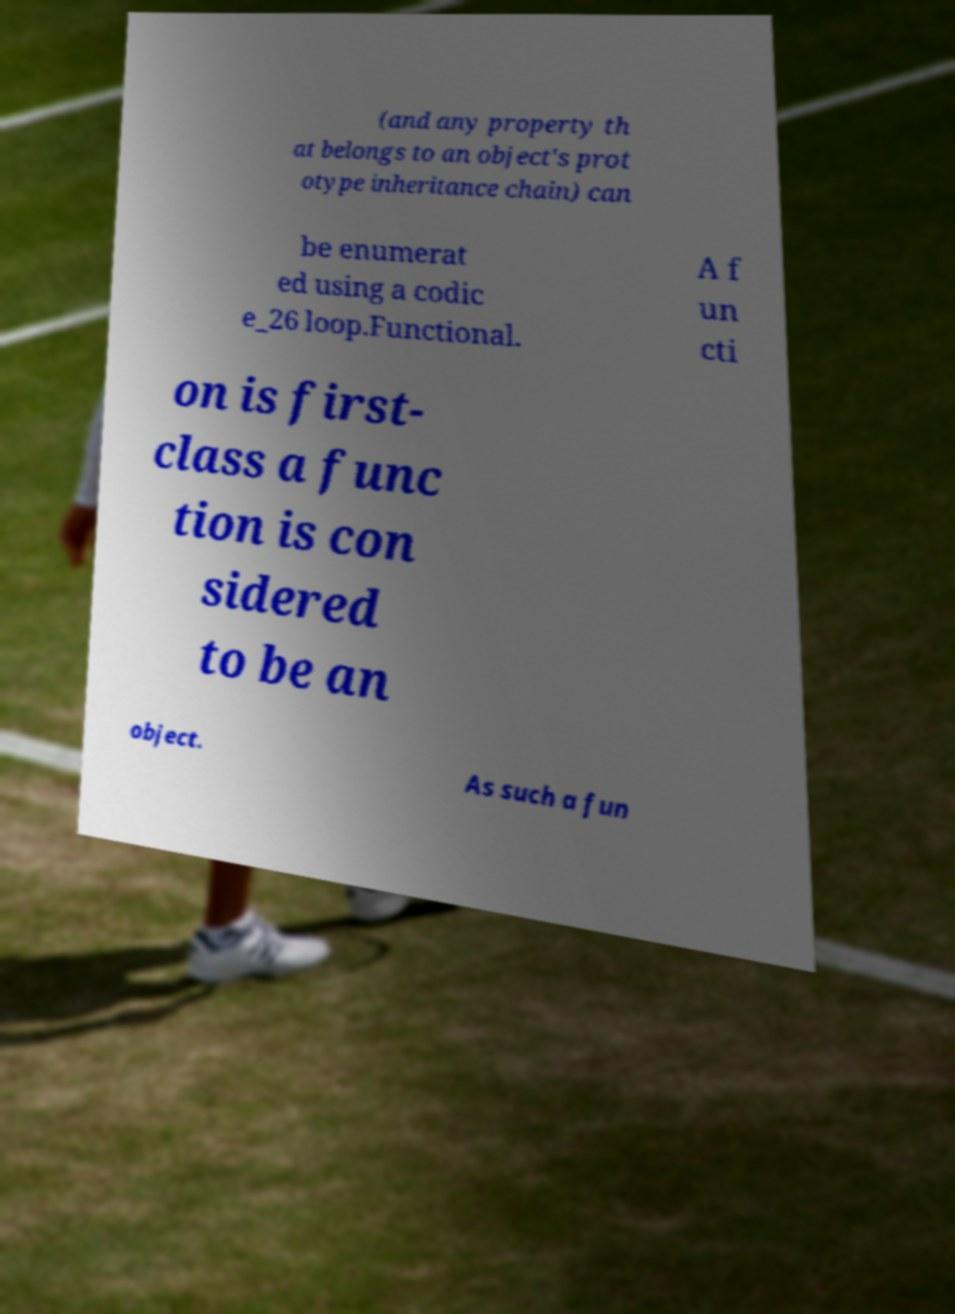Can you accurately transcribe the text from the provided image for me? (and any property th at belongs to an object's prot otype inheritance chain) can be enumerat ed using a codic e_26 loop.Functional. A f un cti on is first- class a func tion is con sidered to be an object. As such a fun 